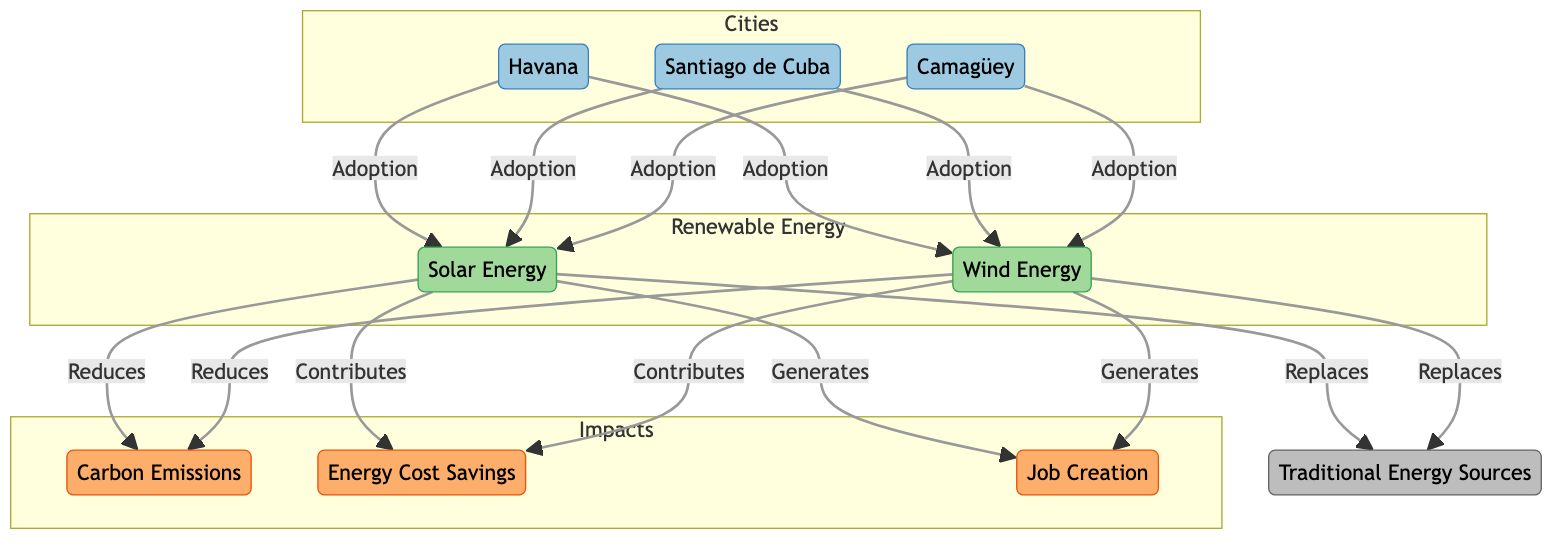What energy sources replace traditional energy in Cuba? The diagram shows that solar energy and wind energy both replace traditional energy sources. This is indicated by the arrows pointing from solar and wind energy to traditional energy sources.
Answer: Solar Energy, Wind Energy Which cities are adopting renewable energy sources? Havana, Santiago de Cuba, and Camagüey are the cities mentioned in the diagram that adopt solar and wind energy. Each city node has an arrow indicating its adoption of these renewable resources.
Answer: Havana, Santiago de Cuba, Camagüey What impact do solar and wind energy have on carbon emissions? The diagram illustrates that both solar and wind energy reduce carbon emissions. This is shown by the arrows leading from solar and wind energy to the carbon emissions node, indicating a reduction effect.
Answer: Reduces How do renewable energy sources contribute to job creation in Cuba? The diagram indicates that both solar and wind energy generate job creation. The arrows from solar and wind energy to job creation clarify that adopting these renewable sources results in job generation.
Answer: Generates What is the relationship between energy cost savings and renewable energy sources? According to the diagram, both solar and wind energy contribute to energy cost savings. This is shown by the arrows connecting solar and wind energy to the energy cost savings node, indicating a positive financial impact.
Answer: Contributes How many main impacts are defined in the diagram? There are three main impacts defined: carbon emissions, energy cost savings, and job creation. The diagram showcases these impacts in a grouped section labeled "Impacts." Counting each distinct impact gives the result.
Answer: Three What is the main purpose of the diagram? The primary purpose of the diagram is to illustrate the impact of renewable energy adoption in Cuba across various dimensions such as carbon emissions reduction, energy cost savings, and job creation. This is inferred from the connections and themes represented by the nodes.
Answer: Impact of Renewable Energy Adoption Which type of energy is highlighted for job generation? The diagram highlights both solar and wind energy as the sources that generate jobs. The arrows leading from these energy types to job creation show their direct contribution to employment.
Answer: Solar Energy, Wind Energy 